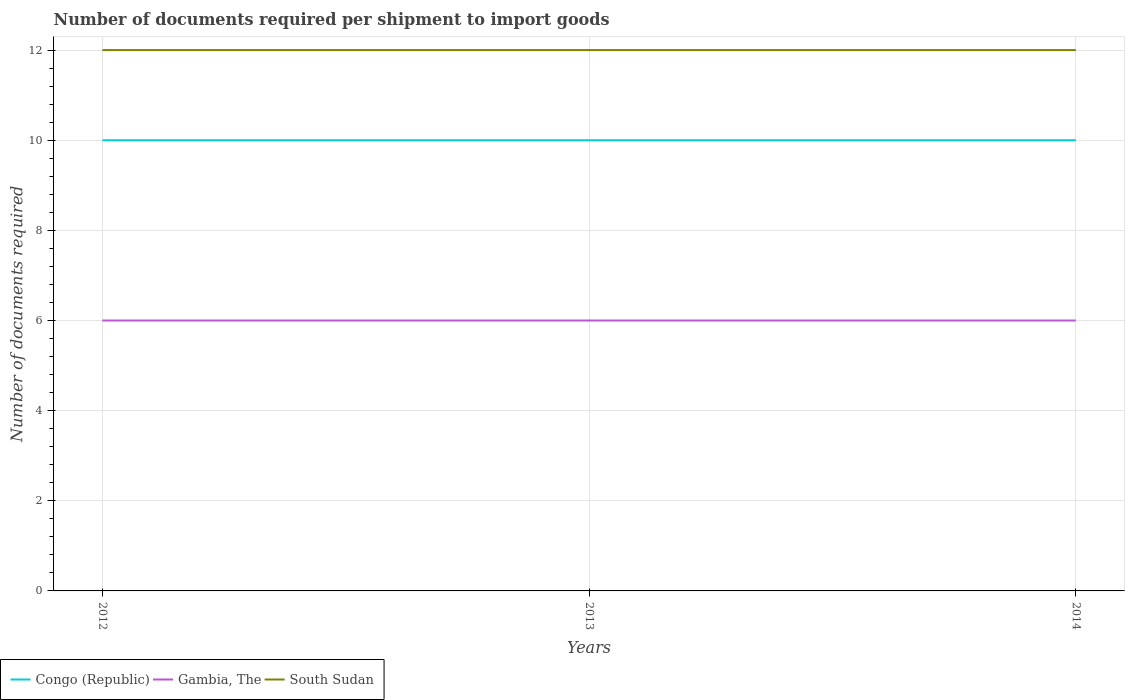Does the line corresponding to South Sudan intersect with the line corresponding to Gambia, The?
Offer a very short reply. No. Across all years, what is the maximum number of documents required per shipment to import goods in Congo (Republic)?
Give a very brief answer. 10. What is the total number of documents required per shipment to import goods in Congo (Republic) in the graph?
Ensure brevity in your answer.  0. Is the number of documents required per shipment to import goods in Gambia, The strictly greater than the number of documents required per shipment to import goods in South Sudan over the years?
Offer a terse response. Yes. How many lines are there?
Make the answer very short. 3. Are the values on the major ticks of Y-axis written in scientific E-notation?
Offer a very short reply. No. Does the graph contain grids?
Ensure brevity in your answer.  Yes. Where does the legend appear in the graph?
Offer a very short reply. Bottom left. How are the legend labels stacked?
Your answer should be very brief. Horizontal. What is the title of the graph?
Ensure brevity in your answer.  Number of documents required per shipment to import goods. Does "South Sudan" appear as one of the legend labels in the graph?
Keep it short and to the point. Yes. What is the label or title of the Y-axis?
Your response must be concise. Number of documents required. What is the Number of documents required in South Sudan in 2012?
Your answer should be compact. 12. What is the Number of documents required of Congo (Republic) in 2013?
Ensure brevity in your answer.  10. What is the Number of documents required of Gambia, The in 2013?
Provide a short and direct response. 6. What is the Number of documents required of South Sudan in 2013?
Offer a very short reply. 12. What is the Number of documents required of Congo (Republic) in 2014?
Your answer should be compact. 10. Across all years, what is the maximum Number of documents required in South Sudan?
Provide a short and direct response. 12. Across all years, what is the minimum Number of documents required in Congo (Republic)?
Offer a terse response. 10. What is the total Number of documents required in Congo (Republic) in the graph?
Offer a very short reply. 30. What is the total Number of documents required in Gambia, The in the graph?
Offer a terse response. 18. What is the total Number of documents required of South Sudan in the graph?
Provide a succinct answer. 36. What is the difference between the Number of documents required of Congo (Republic) in 2012 and that in 2013?
Offer a very short reply. 0. What is the difference between the Number of documents required in Congo (Republic) in 2012 and that in 2014?
Your response must be concise. 0. What is the difference between the Number of documents required of Gambia, The in 2012 and that in 2014?
Your response must be concise. 0. What is the difference between the Number of documents required in Congo (Republic) in 2013 and that in 2014?
Make the answer very short. 0. What is the difference between the Number of documents required of Gambia, The in 2013 and that in 2014?
Give a very brief answer. 0. What is the difference between the Number of documents required of South Sudan in 2013 and that in 2014?
Your response must be concise. 0. What is the difference between the Number of documents required of Congo (Republic) in 2012 and the Number of documents required of South Sudan in 2013?
Ensure brevity in your answer.  -2. What is the difference between the Number of documents required in Gambia, The in 2012 and the Number of documents required in South Sudan in 2013?
Give a very brief answer. -6. What is the difference between the Number of documents required of Congo (Republic) in 2012 and the Number of documents required of Gambia, The in 2014?
Your response must be concise. 4. What is the difference between the Number of documents required in Congo (Republic) in 2012 and the Number of documents required in South Sudan in 2014?
Provide a short and direct response. -2. What is the difference between the Number of documents required of Gambia, The in 2012 and the Number of documents required of South Sudan in 2014?
Your answer should be compact. -6. What is the difference between the Number of documents required in Congo (Republic) in 2013 and the Number of documents required in Gambia, The in 2014?
Give a very brief answer. 4. What is the difference between the Number of documents required in Congo (Republic) in 2013 and the Number of documents required in South Sudan in 2014?
Provide a succinct answer. -2. What is the average Number of documents required in Congo (Republic) per year?
Offer a very short reply. 10. What is the average Number of documents required of South Sudan per year?
Your answer should be compact. 12. In the year 2012, what is the difference between the Number of documents required of Congo (Republic) and Number of documents required of Gambia, The?
Your answer should be very brief. 4. In the year 2012, what is the difference between the Number of documents required in Congo (Republic) and Number of documents required in South Sudan?
Give a very brief answer. -2. In the year 2013, what is the difference between the Number of documents required of Congo (Republic) and Number of documents required of South Sudan?
Your answer should be compact. -2. In the year 2013, what is the difference between the Number of documents required of Gambia, The and Number of documents required of South Sudan?
Offer a terse response. -6. In the year 2014, what is the difference between the Number of documents required of Congo (Republic) and Number of documents required of Gambia, The?
Your response must be concise. 4. What is the ratio of the Number of documents required in Gambia, The in 2012 to that in 2013?
Offer a very short reply. 1. What is the ratio of the Number of documents required of South Sudan in 2012 to that in 2013?
Keep it short and to the point. 1. What is the ratio of the Number of documents required in Congo (Republic) in 2012 to that in 2014?
Make the answer very short. 1. What is the ratio of the Number of documents required of Gambia, The in 2012 to that in 2014?
Ensure brevity in your answer.  1. What is the ratio of the Number of documents required of Gambia, The in 2013 to that in 2014?
Your response must be concise. 1. What is the difference between the highest and the lowest Number of documents required of Gambia, The?
Your response must be concise. 0. What is the difference between the highest and the lowest Number of documents required of South Sudan?
Offer a terse response. 0. 